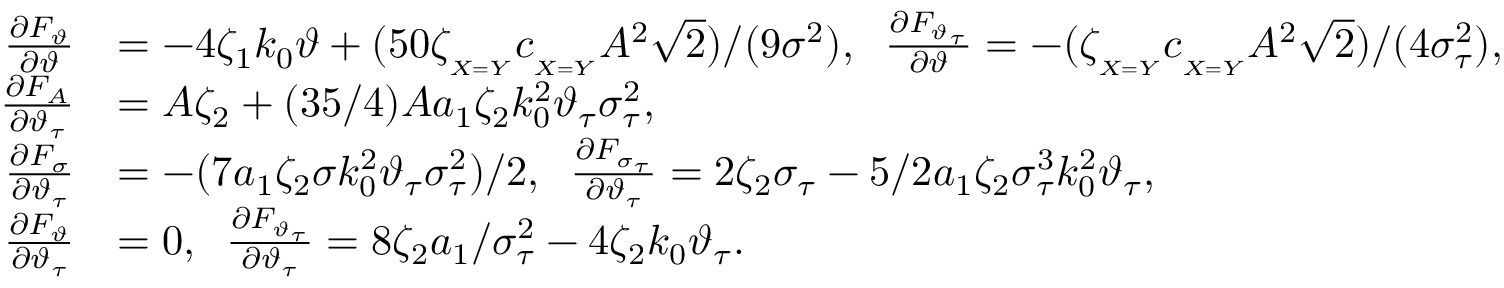Convert formula to latex. <formula><loc_0><loc_0><loc_500><loc_500>\begin{array} { r l } { \frac { \partial F _ { \vartheta } } { \partial \vartheta } } & { = - 4 \zeta _ { 1 } k _ { 0 } \vartheta + ( 5 0 \zeta _ { _ { X = Y } } c _ { _ { X = Y } } A ^ { 2 } \sqrt { 2 } ) / ( 9 \sigma ^ { 2 } ) , \, \frac { \partial F _ { \vartheta _ { \tau } } } { \partial \vartheta } = - ( \zeta _ { _ { X = Y } } c _ { _ { X = Y } } A ^ { 2 } \sqrt { 2 } ) / ( 4 \sigma _ { \tau } ^ { 2 } ) , } \\ { \frac { \partial F _ { A } } { \partial \vartheta _ { \tau } } } & { = A \zeta _ { 2 } + ( 3 5 / 4 ) A a _ { 1 } \zeta _ { 2 } k _ { 0 } ^ { 2 } \vartheta _ { \tau } \sigma _ { \tau } ^ { 2 } , } \\ { \frac { \partial F _ { \sigma } } { \partial \vartheta _ { \tau } } } & { = - ( 7 a _ { 1 } \zeta _ { 2 } \sigma k _ { 0 } ^ { 2 } \vartheta _ { \tau } \sigma _ { \tau } ^ { 2 } ) / 2 , \, \frac { \partial F _ { \sigma _ { \tau } } } { \partial \vartheta _ { \tau } } = 2 \zeta _ { 2 } \sigma _ { \tau } - 5 / 2 a _ { 1 } \zeta _ { 2 } \sigma _ { \tau } ^ { 3 } k _ { 0 } ^ { 2 } \vartheta _ { \tau } , } \\ { \frac { \partial F _ { \vartheta } } { \partial \vartheta _ { \tau } } } & { = 0 , \, \frac { \partial F _ { \vartheta _ { \tau } } } { \partial \vartheta _ { \tau } } = 8 \zeta _ { 2 } a _ { 1 } / \sigma _ { \tau } ^ { 2 } - 4 \zeta _ { 2 } k _ { 0 } \vartheta _ { \tau } . } \end{array}</formula> 